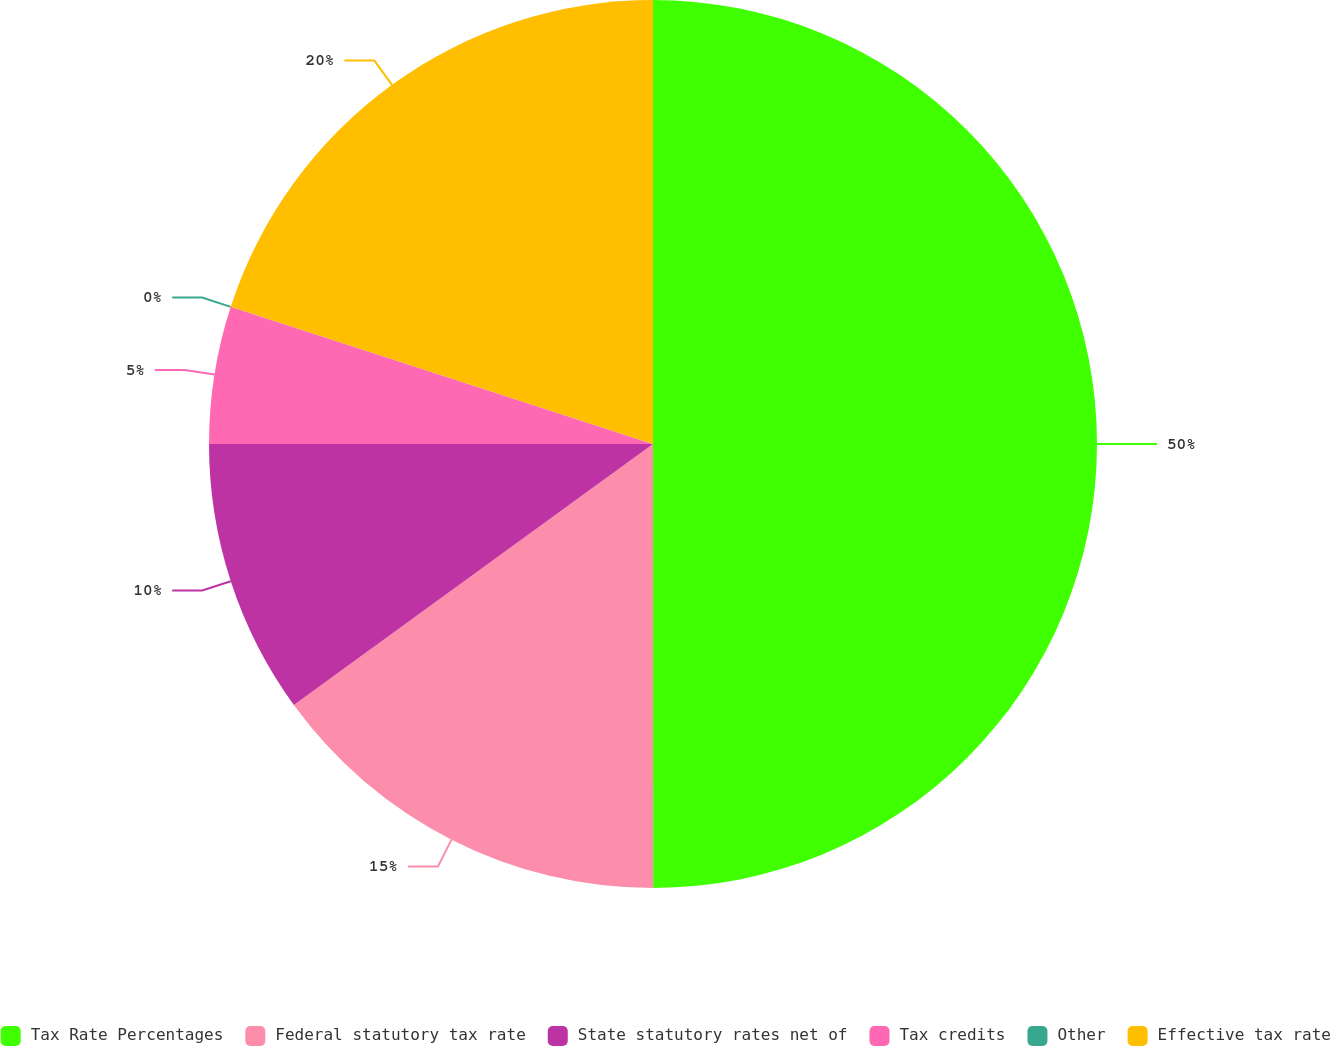<chart> <loc_0><loc_0><loc_500><loc_500><pie_chart><fcel>Tax Rate Percentages<fcel>Federal statutory tax rate<fcel>State statutory rates net of<fcel>Tax credits<fcel>Other<fcel>Effective tax rate<nl><fcel>49.99%<fcel>15.0%<fcel>10.0%<fcel>5.0%<fcel>0.0%<fcel>20.0%<nl></chart> 